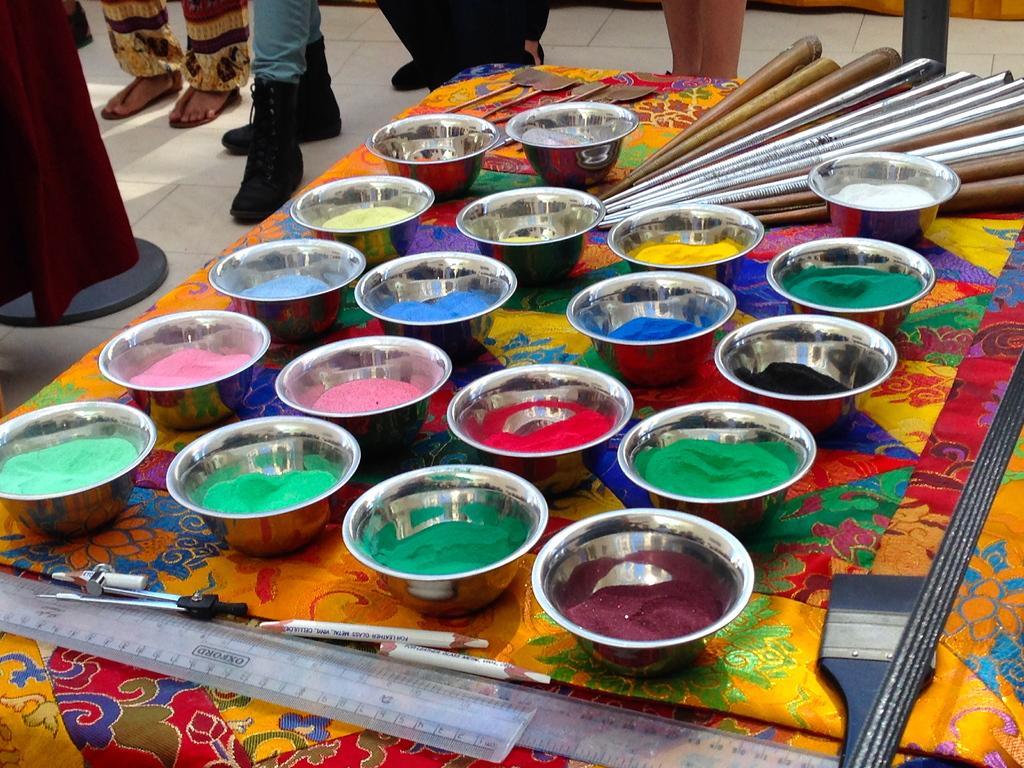Describe this image in one or two sentences. In this image we can see different colors in the bowls, scales, pencils, compass and objects on a cloth on the table. In the background we can see few persons legs on the floor and other objects. 